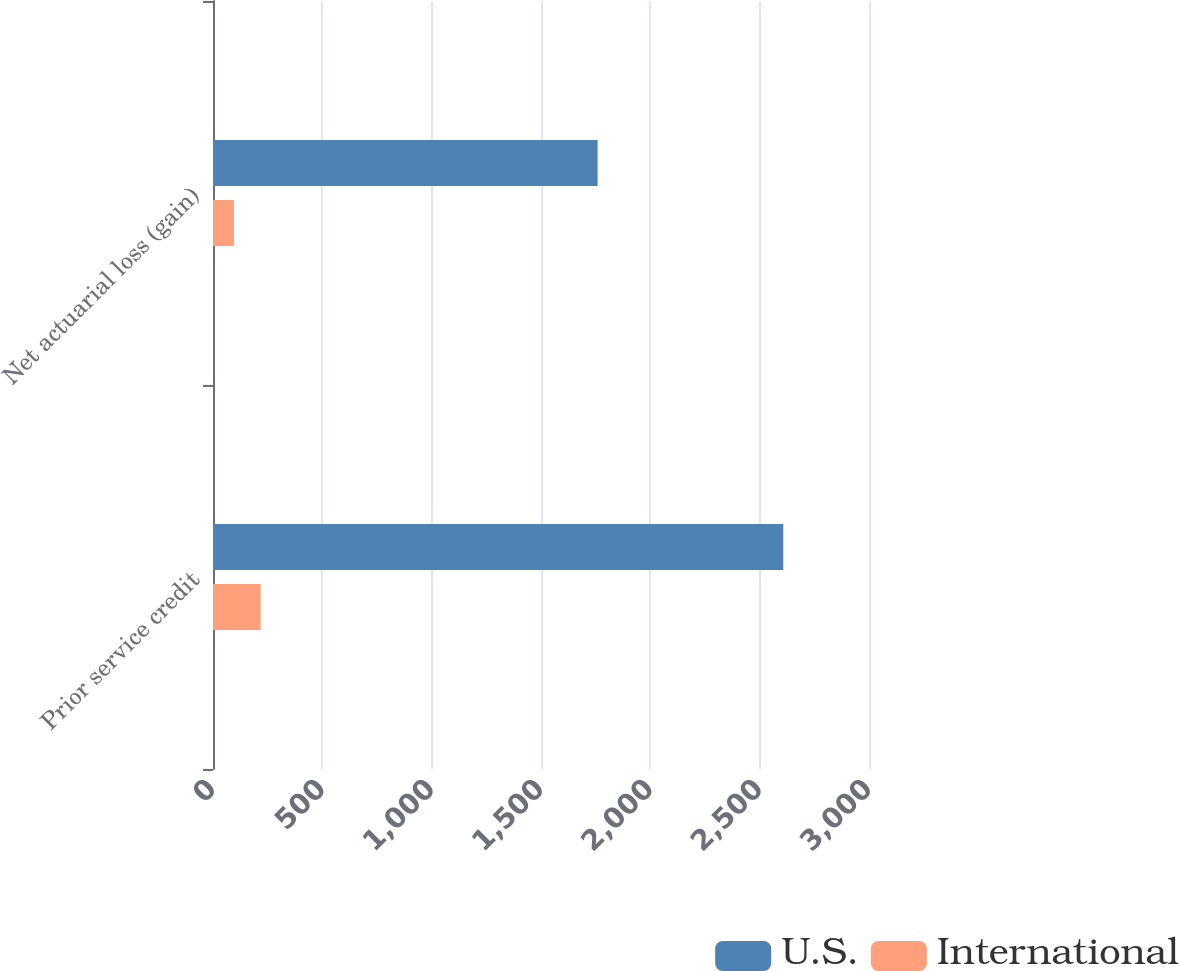<chart> <loc_0><loc_0><loc_500><loc_500><stacked_bar_chart><ecel><fcel>Prior service credit<fcel>Net actuarial loss (gain)<nl><fcel>U.S.<fcel>2608<fcel>1759<nl><fcel>International<fcel>218<fcel>96<nl></chart> 